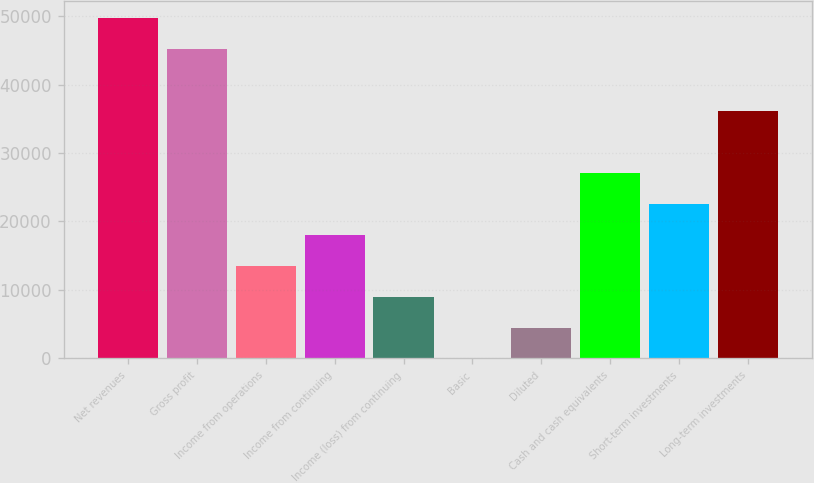<chart> <loc_0><loc_0><loc_500><loc_500><bar_chart><fcel>Net revenues<fcel>Gross profit<fcel>Income from operations<fcel>Income from continuing<fcel>Income (loss) from continuing<fcel>Basic<fcel>Diluted<fcel>Cash and cash equivalents<fcel>Short-term investments<fcel>Long-term investments<nl><fcel>49645.1<fcel>45132<fcel>13540.1<fcel>18053.2<fcel>9026.95<fcel>0.69<fcel>4513.82<fcel>27079.5<fcel>22566.3<fcel>36105.7<nl></chart> 